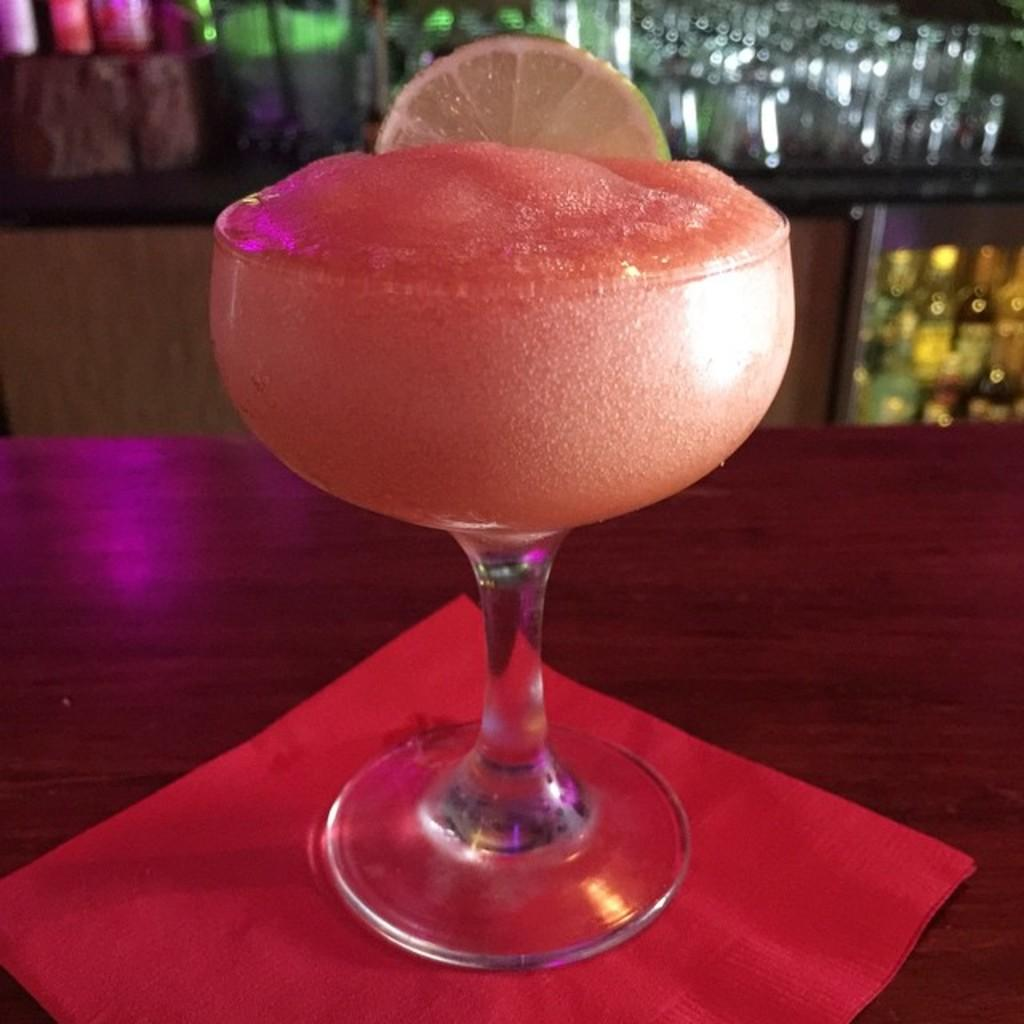What is in the glass that is visible in the image? There is a glass with juice in the image. What is added to the juice in the glass? There is a slice of lemon in the glass. Where is the glass placed in the image? The glass is placed on a table. What can be seen in the background of the image? There are bottles and glasses in a wooden cupboard in the background of the image. What type of doctor is attending to the patient in the image? There is no patient or doctor present in the image; it features a glass with juice and a slice of lemon. Where did the family go on vacation in the image? There is no reference to a family or a vacation in the image. 